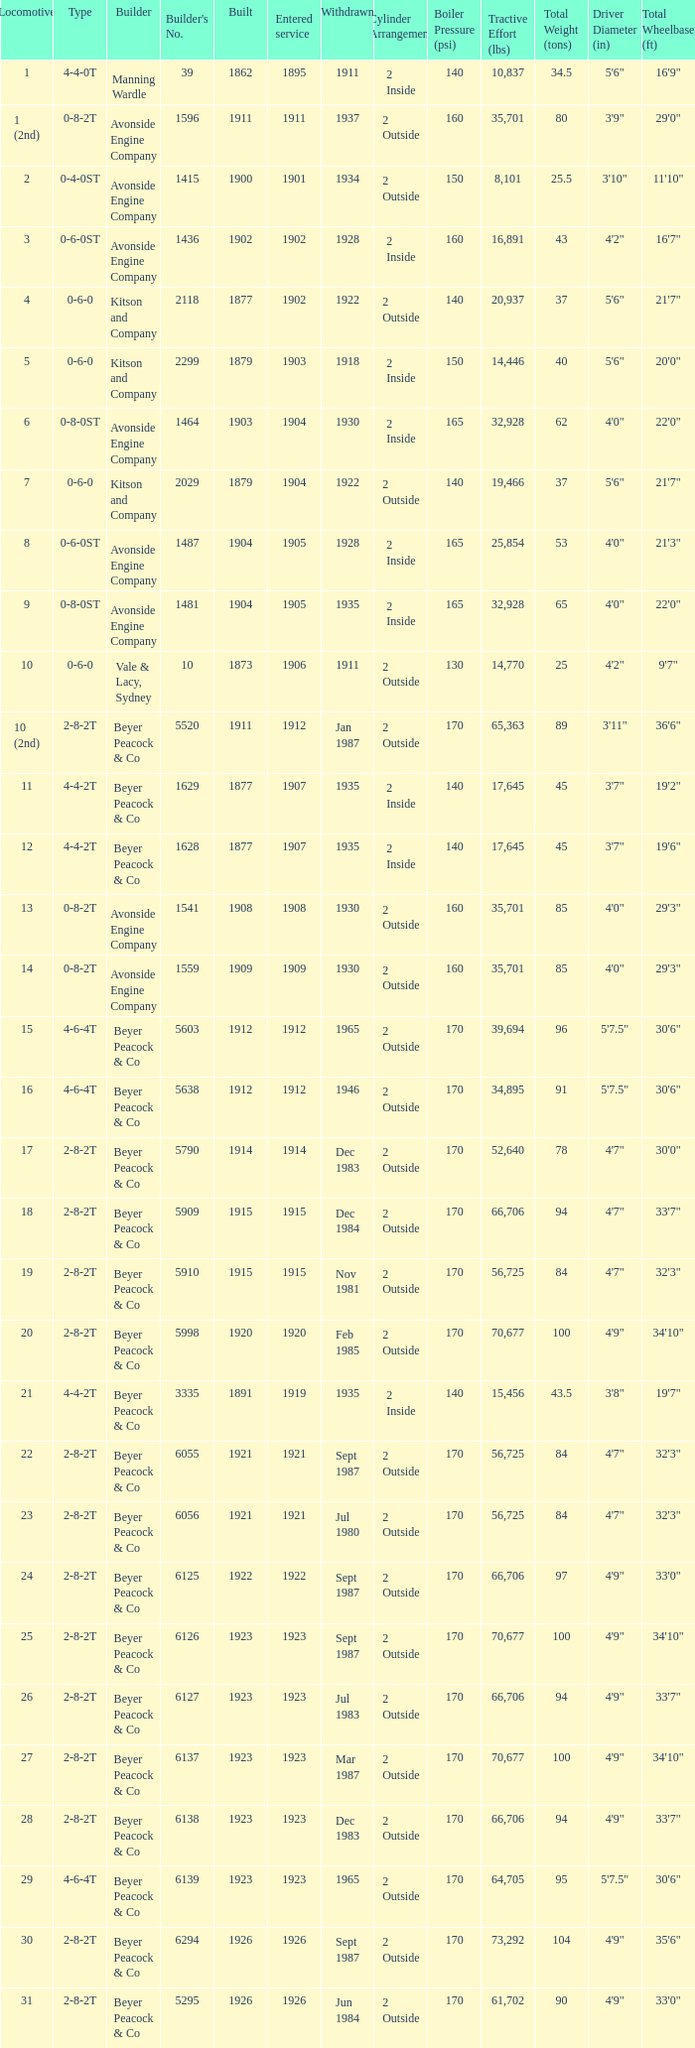How many years entered service when there were 13 locomotives? 1.0. 